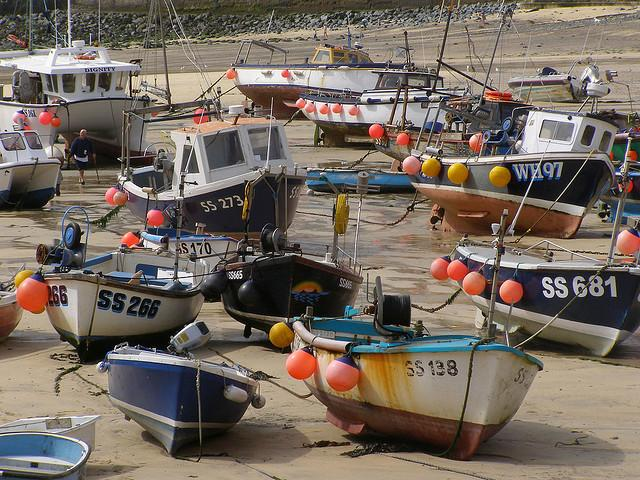What boat number is the largest here?

Choices:
A) 9986
B) 273
C) 1812
D) 681 681 